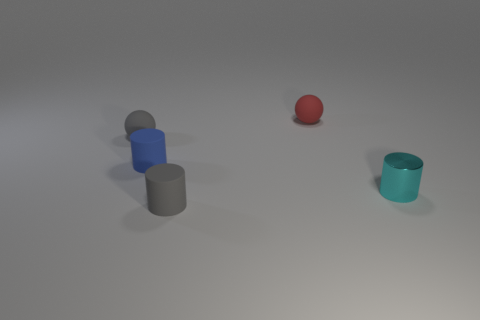Subtract all matte cylinders. How many cylinders are left? 1 Subtract all blue cylinders. How many cylinders are left? 2 Subtract all cylinders. How many objects are left? 2 Subtract all yellow cylinders. How many yellow spheres are left? 0 Subtract 2 cylinders. How many cylinders are left? 1 Subtract all cyan cylinders. Subtract all gray blocks. How many cylinders are left? 2 Subtract all tiny gray rubber cylinders. Subtract all matte cylinders. How many objects are left? 2 Add 4 tiny cyan metallic cylinders. How many tiny cyan metallic cylinders are left? 5 Add 5 red matte balls. How many red matte balls exist? 6 Add 1 small blue rubber objects. How many objects exist? 6 